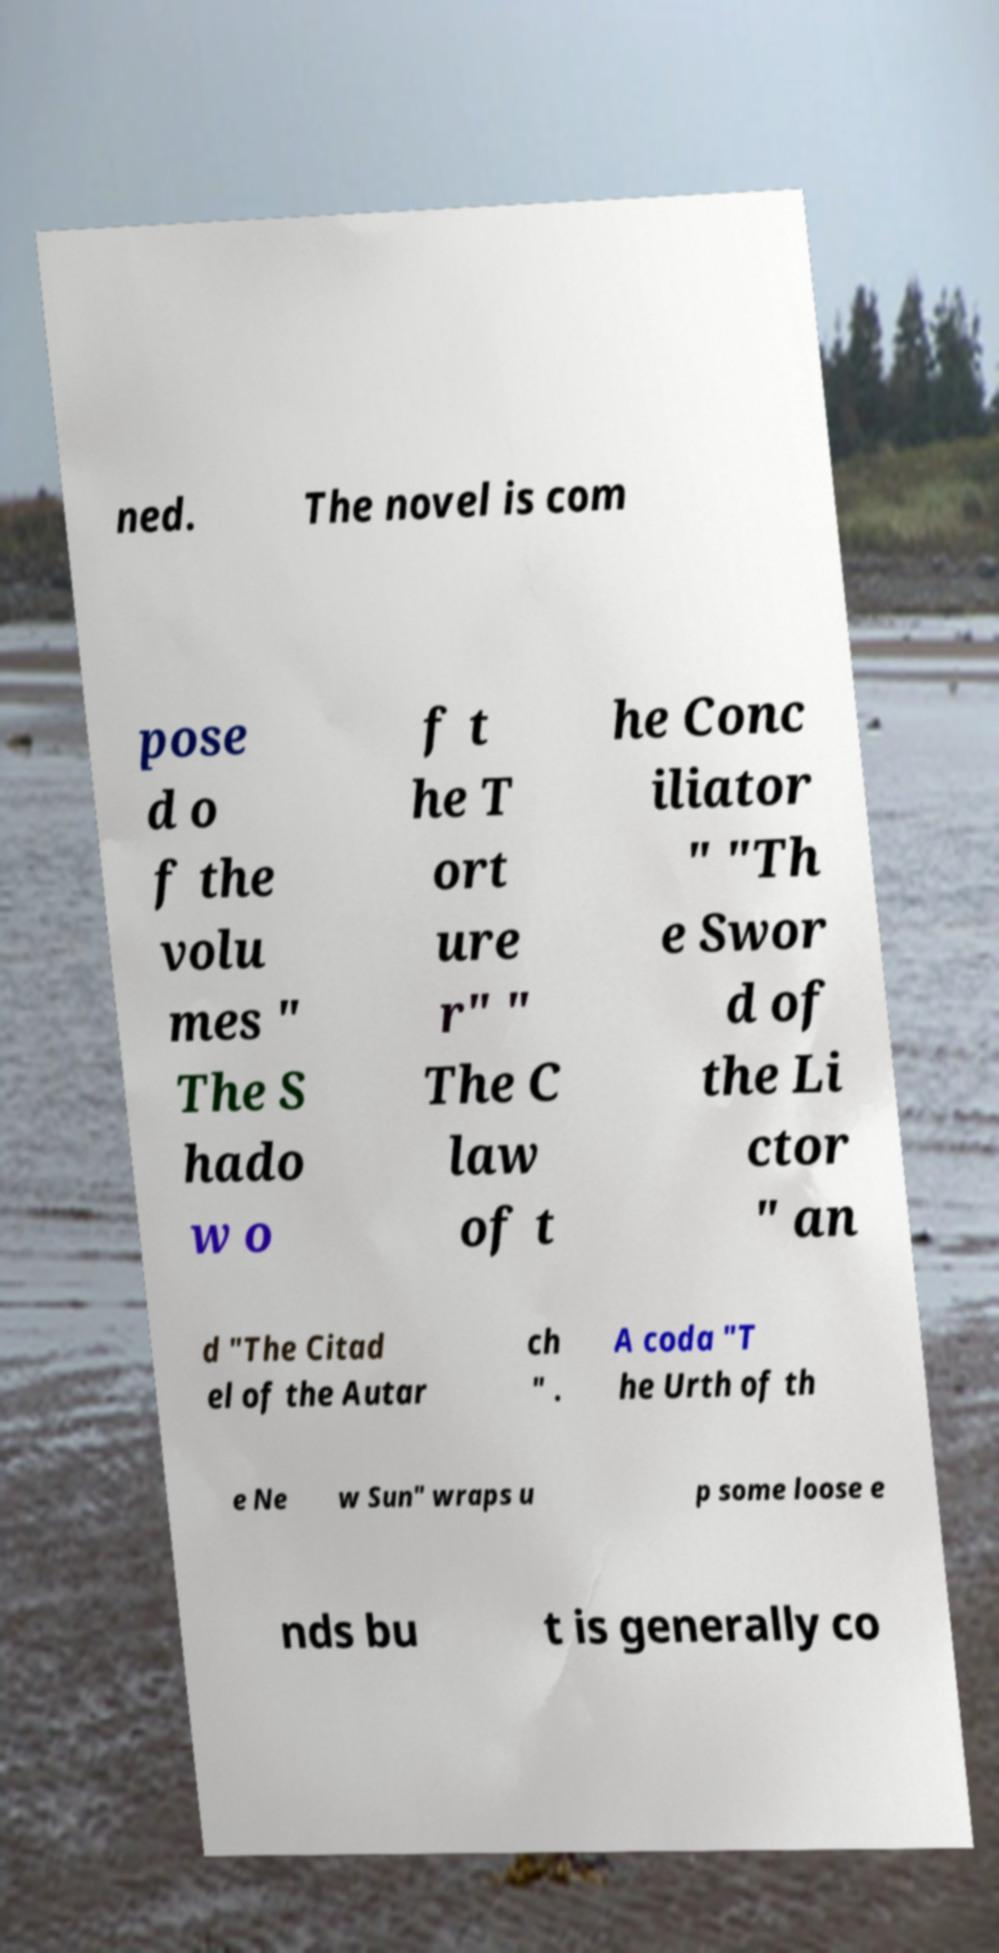For documentation purposes, I need the text within this image transcribed. Could you provide that? ned. The novel is com pose d o f the volu mes " The S hado w o f t he T ort ure r" " The C law of t he Conc iliator " "Th e Swor d of the Li ctor " an d "The Citad el of the Autar ch " . A coda "T he Urth of th e Ne w Sun" wraps u p some loose e nds bu t is generally co 